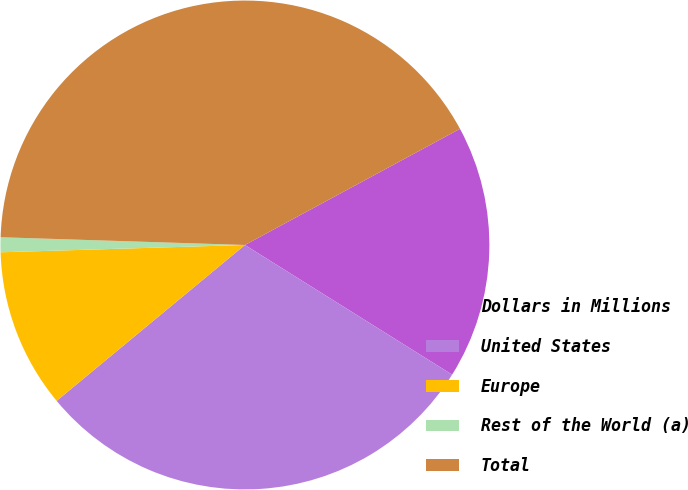<chart> <loc_0><loc_0><loc_500><loc_500><pie_chart><fcel>Dollars in Millions<fcel>United States<fcel>Europe<fcel>Rest of the World (a)<fcel>Total<nl><fcel>16.78%<fcel>30.09%<fcel>10.53%<fcel>0.98%<fcel>41.61%<nl></chart> 